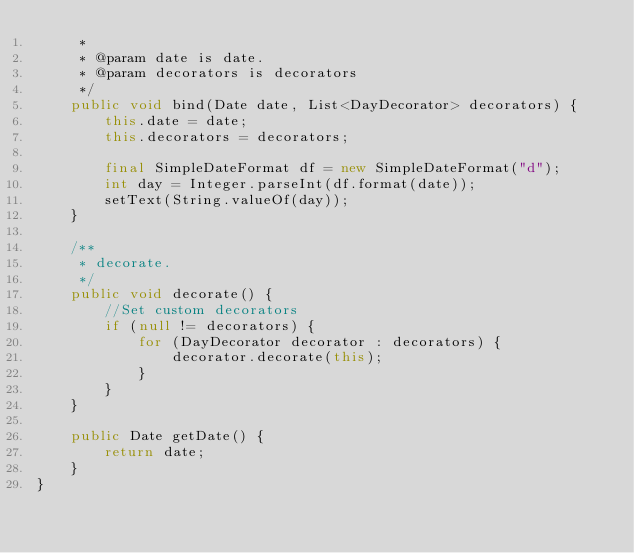Convert code to text. <code><loc_0><loc_0><loc_500><loc_500><_Java_>     *
     * @param date is date.
     * @param decorators is decorators
     */
    public void bind(Date date, List<DayDecorator> decorators) {
        this.date = date;
        this.decorators = decorators;

        final SimpleDateFormat df = new SimpleDateFormat("d");
        int day = Integer.parseInt(df.format(date));
        setText(String.valueOf(day));
    }

    /**
     * decorate.
     */
    public void decorate() {
        //Set custom decorators
        if (null != decorators) {
            for (DayDecorator decorator : decorators) {
                decorator.decorate(this);
            }
        }
    }

    public Date getDate() {
        return date;
    }
}</code> 